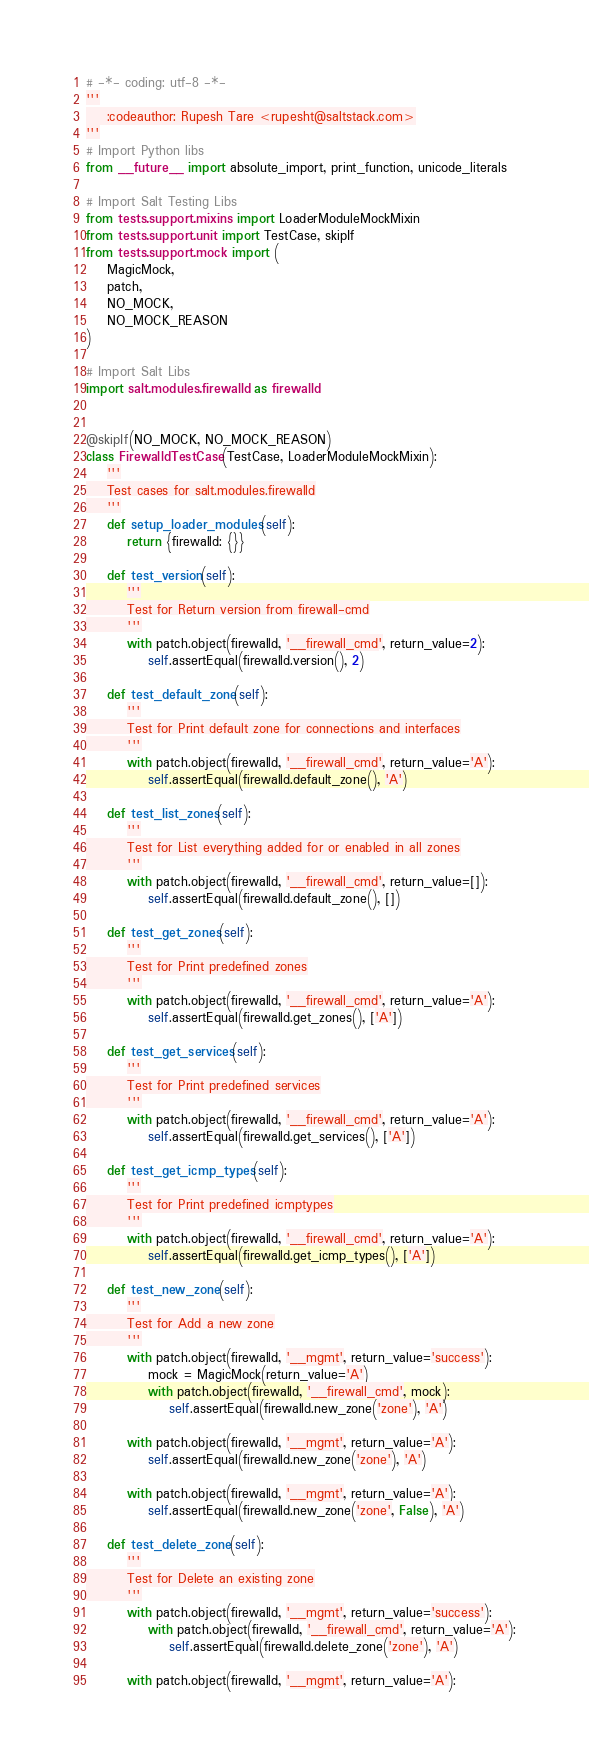<code> <loc_0><loc_0><loc_500><loc_500><_Python_># -*- coding: utf-8 -*-
'''
    :codeauthor: Rupesh Tare <rupesht@saltstack.com>
'''
# Import Python libs
from __future__ import absolute_import, print_function, unicode_literals

# Import Salt Testing Libs
from tests.support.mixins import LoaderModuleMockMixin
from tests.support.unit import TestCase, skipIf
from tests.support.mock import (
    MagicMock,
    patch,
    NO_MOCK,
    NO_MOCK_REASON
)

# Import Salt Libs
import salt.modules.firewalld as firewalld


@skipIf(NO_MOCK, NO_MOCK_REASON)
class FirewalldTestCase(TestCase, LoaderModuleMockMixin):
    '''
    Test cases for salt.modules.firewalld
    '''
    def setup_loader_modules(self):
        return {firewalld: {}}

    def test_version(self):
        '''
        Test for Return version from firewall-cmd
        '''
        with patch.object(firewalld, '__firewall_cmd', return_value=2):
            self.assertEqual(firewalld.version(), 2)

    def test_default_zone(self):
        '''
        Test for Print default zone for connections and interfaces
        '''
        with patch.object(firewalld, '__firewall_cmd', return_value='A'):
            self.assertEqual(firewalld.default_zone(), 'A')

    def test_list_zones(self):
        '''
        Test for List everything added for or enabled in all zones
        '''
        with patch.object(firewalld, '__firewall_cmd', return_value=[]):
            self.assertEqual(firewalld.default_zone(), [])

    def test_get_zones(self):
        '''
        Test for Print predefined zones
        '''
        with patch.object(firewalld, '__firewall_cmd', return_value='A'):
            self.assertEqual(firewalld.get_zones(), ['A'])

    def test_get_services(self):
        '''
        Test for Print predefined services
        '''
        with patch.object(firewalld, '__firewall_cmd', return_value='A'):
            self.assertEqual(firewalld.get_services(), ['A'])

    def test_get_icmp_types(self):
        '''
        Test for Print predefined icmptypes
        '''
        with patch.object(firewalld, '__firewall_cmd', return_value='A'):
            self.assertEqual(firewalld.get_icmp_types(), ['A'])

    def test_new_zone(self):
        '''
        Test for Add a new zone
        '''
        with patch.object(firewalld, '__mgmt', return_value='success'):
            mock = MagicMock(return_value='A')
            with patch.object(firewalld, '__firewall_cmd', mock):
                self.assertEqual(firewalld.new_zone('zone'), 'A')

        with patch.object(firewalld, '__mgmt', return_value='A'):
            self.assertEqual(firewalld.new_zone('zone'), 'A')

        with patch.object(firewalld, '__mgmt', return_value='A'):
            self.assertEqual(firewalld.new_zone('zone', False), 'A')

    def test_delete_zone(self):
        '''
        Test for Delete an existing zone
        '''
        with patch.object(firewalld, '__mgmt', return_value='success'):
            with patch.object(firewalld, '__firewall_cmd', return_value='A'):
                self.assertEqual(firewalld.delete_zone('zone'), 'A')

        with patch.object(firewalld, '__mgmt', return_value='A'):</code> 